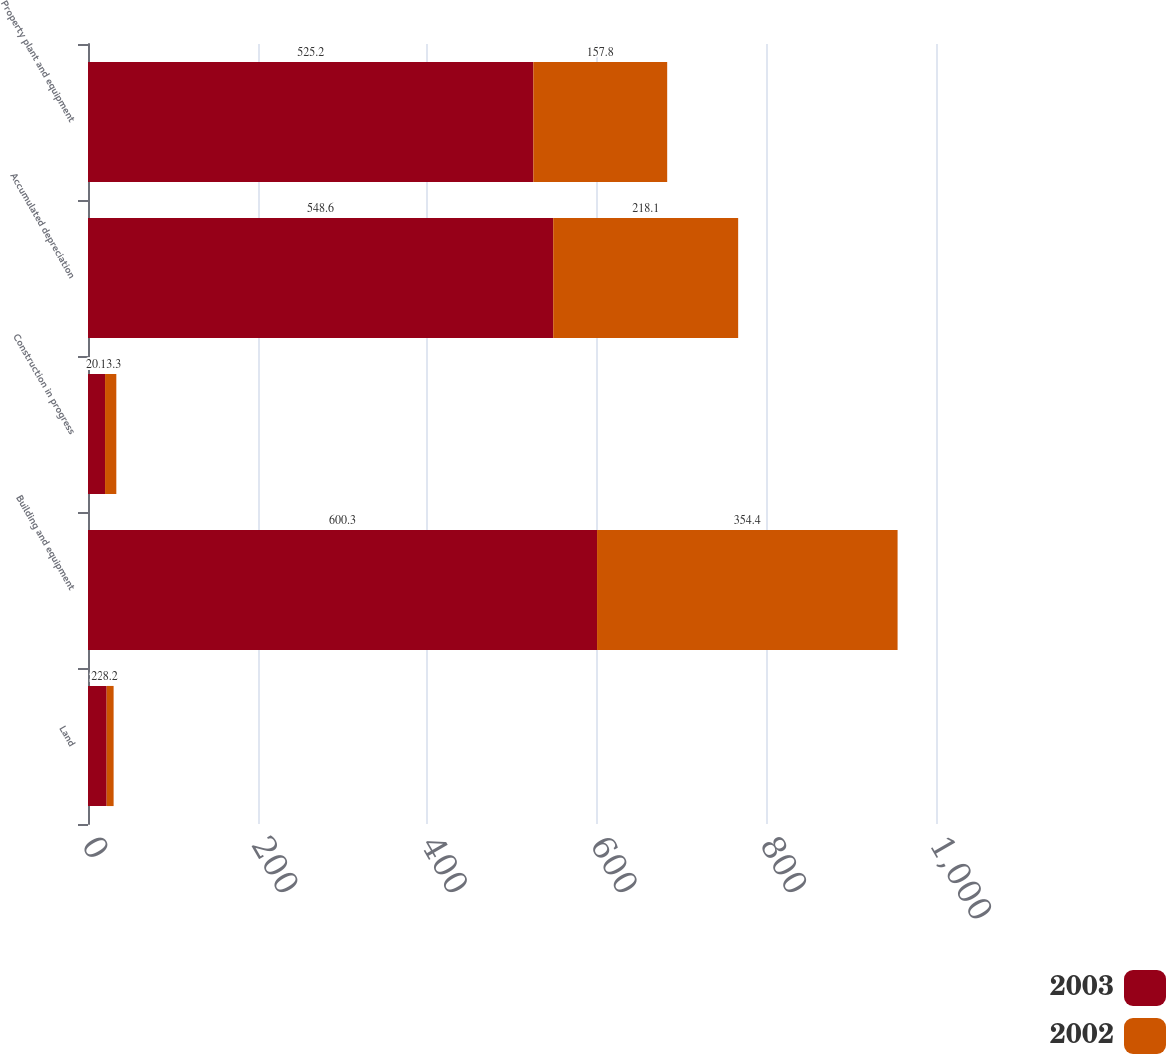<chart> <loc_0><loc_0><loc_500><loc_500><stacked_bar_chart><ecel><fcel>Land<fcel>Building and equipment<fcel>Construction in progress<fcel>Accumulated depreciation<fcel>Property plant and equipment<nl><fcel>2003<fcel>22<fcel>600.3<fcel>20.1<fcel>548.6<fcel>525.2<nl><fcel>2002<fcel>8.2<fcel>354.4<fcel>13.3<fcel>218.1<fcel>157.8<nl></chart> 